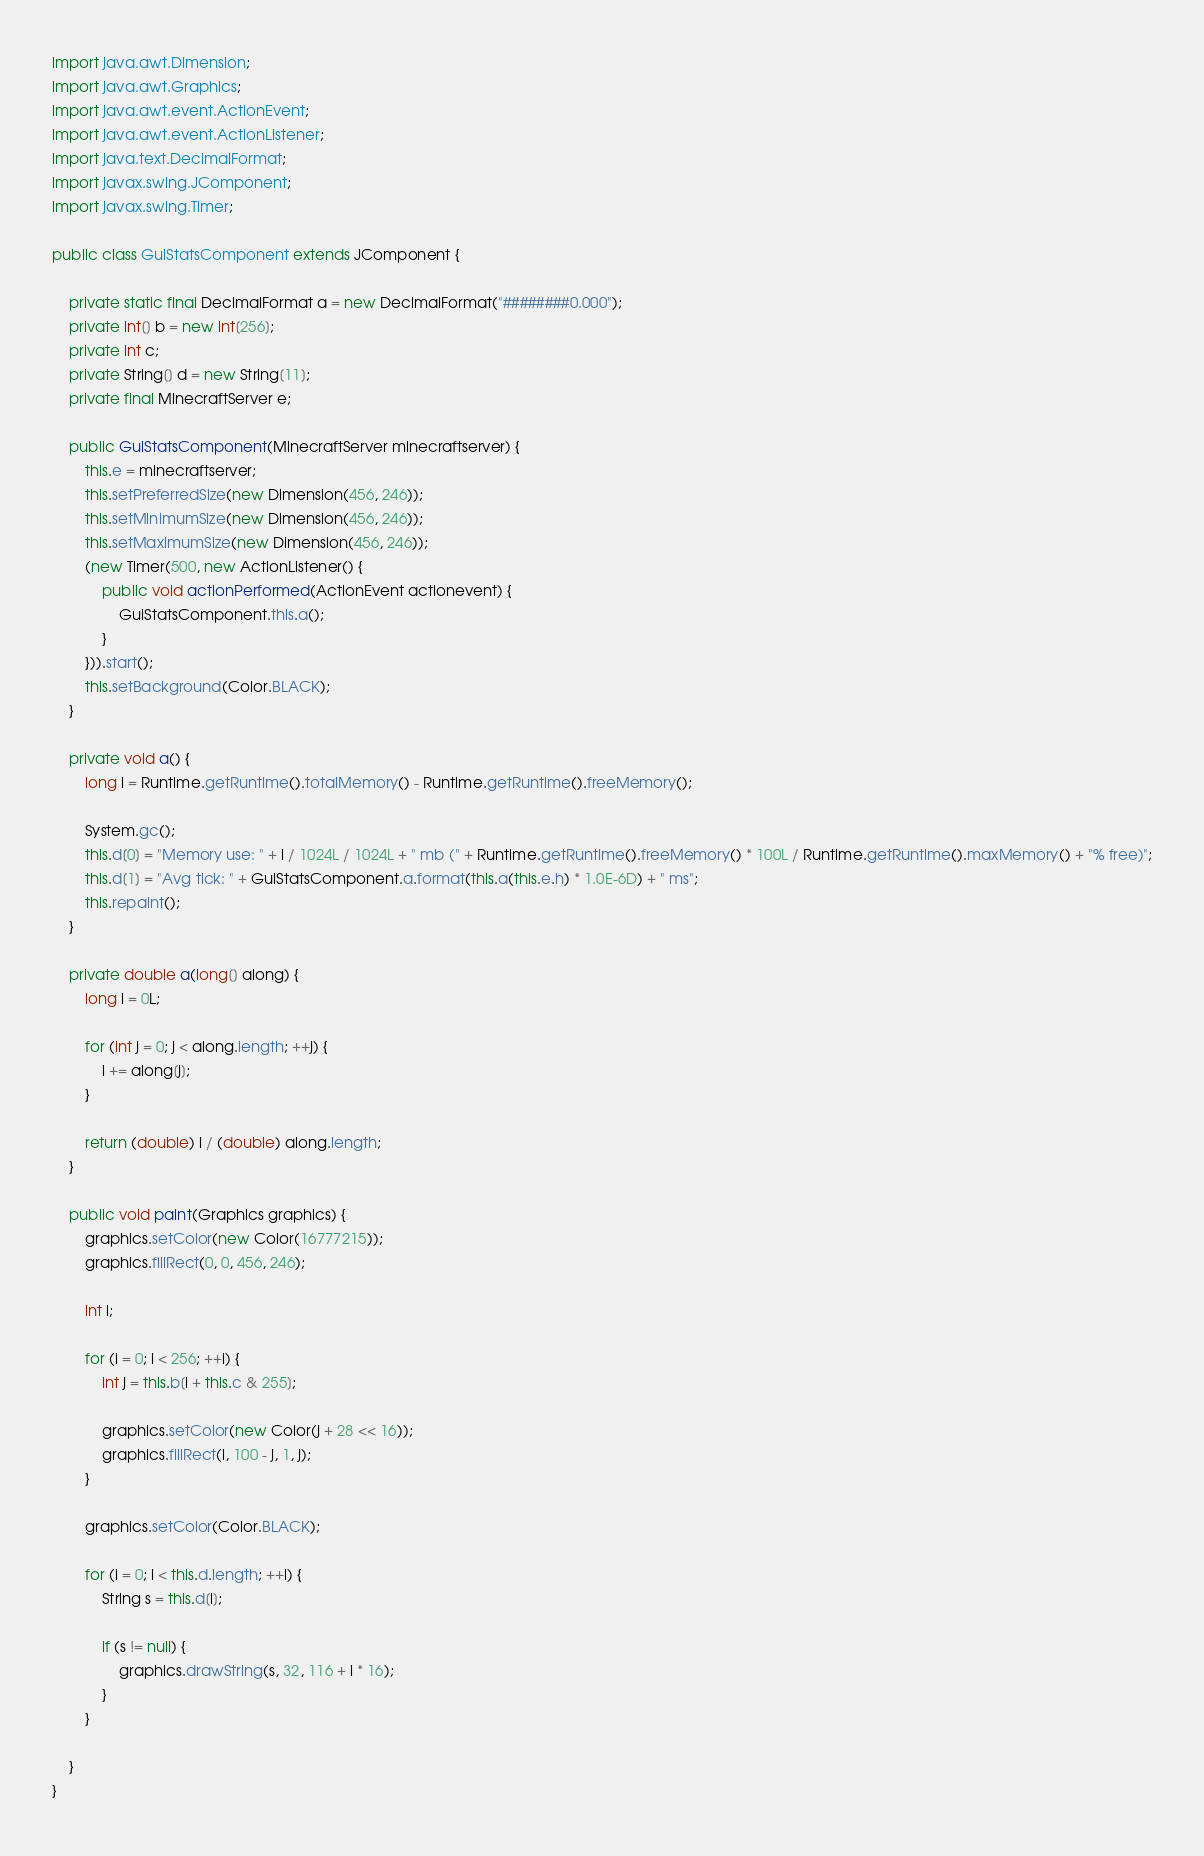Convert code to text. <code><loc_0><loc_0><loc_500><loc_500><_Java_>import java.awt.Dimension;
import java.awt.Graphics;
import java.awt.event.ActionEvent;
import java.awt.event.ActionListener;
import java.text.DecimalFormat;
import javax.swing.JComponent;
import javax.swing.Timer;

public class GuiStatsComponent extends JComponent {

    private static final DecimalFormat a = new DecimalFormat("########0.000");
    private int[] b = new int[256];
    private int c;
    private String[] d = new String[11];
    private final MinecraftServer e;

    public GuiStatsComponent(MinecraftServer minecraftserver) {
        this.e = minecraftserver;
        this.setPreferredSize(new Dimension(456, 246));
        this.setMinimumSize(new Dimension(456, 246));
        this.setMaximumSize(new Dimension(456, 246));
        (new Timer(500, new ActionListener() {
            public void actionPerformed(ActionEvent actionevent) {
                GuiStatsComponent.this.a();
            }
        })).start();
        this.setBackground(Color.BLACK);
    }

    private void a() {
        long i = Runtime.getRuntime().totalMemory() - Runtime.getRuntime().freeMemory();

        System.gc();
        this.d[0] = "Memory use: " + i / 1024L / 1024L + " mb (" + Runtime.getRuntime().freeMemory() * 100L / Runtime.getRuntime().maxMemory() + "% free)";
        this.d[1] = "Avg tick: " + GuiStatsComponent.a.format(this.a(this.e.h) * 1.0E-6D) + " ms";
        this.repaint();
    }

    private double a(long[] along) {
        long i = 0L;

        for (int j = 0; j < along.length; ++j) {
            i += along[j];
        }

        return (double) i / (double) along.length;
    }

    public void paint(Graphics graphics) {
        graphics.setColor(new Color(16777215));
        graphics.fillRect(0, 0, 456, 246);

        int i;

        for (i = 0; i < 256; ++i) {
            int j = this.b[i + this.c & 255];

            graphics.setColor(new Color(j + 28 << 16));
            graphics.fillRect(i, 100 - j, 1, j);
        }

        graphics.setColor(Color.BLACK);

        for (i = 0; i < this.d.length; ++i) {
            String s = this.d[i];

            if (s != null) {
                graphics.drawString(s, 32, 116 + i * 16);
            }
        }

    }
}
</code> 